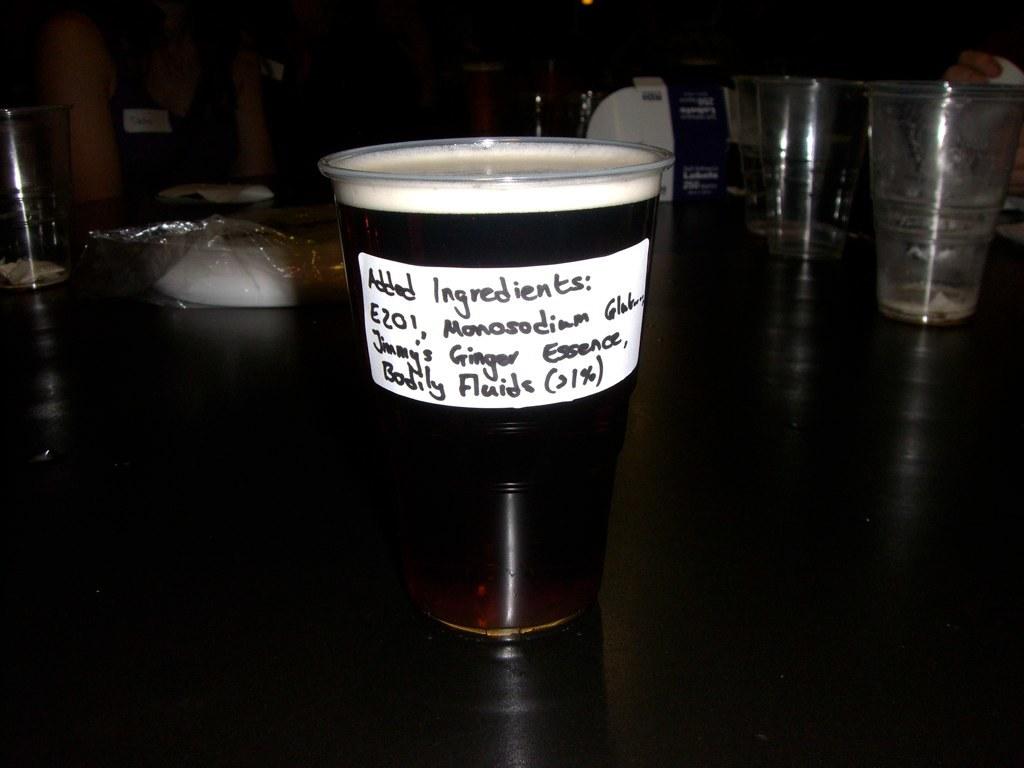What are the ingredients in the drink?
Keep it short and to the point. E201, monosodium gluten, jimmy's ginger essence, bodily fluids. Does this have bodily fluids?
Your answer should be very brief. Yes. 